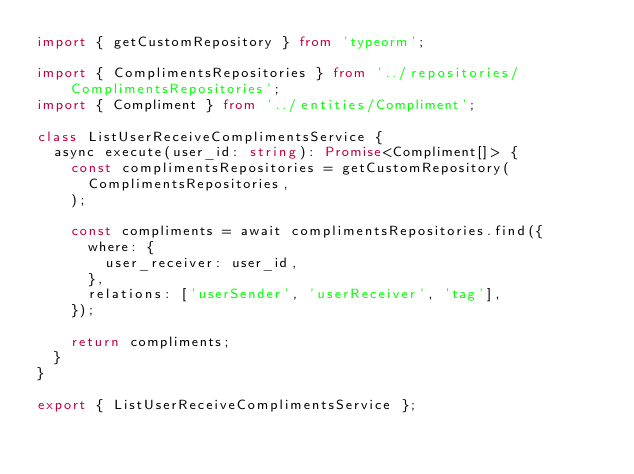<code> <loc_0><loc_0><loc_500><loc_500><_TypeScript_>import { getCustomRepository } from 'typeorm';

import { ComplimentsRepositories } from '../repositories/ComplimentsRepositories';
import { Compliment } from '../entities/Compliment';

class ListUserReceiveComplimentsService {
  async execute(user_id: string): Promise<Compliment[]> {
    const complimentsRepositories = getCustomRepository(
      ComplimentsRepositories,
    );

    const compliments = await complimentsRepositories.find({
      where: {
        user_receiver: user_id,
      },
      relations: ['userSender', 'userReceiver', 'tag'],
    });

    return compliments;
  }
}

export { ListUserReceiveComplimentsService };
</code> 